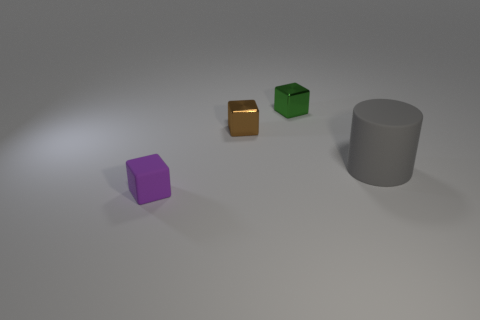Subtract all red blocks. Subtract all green cylinders. How many blocks are left? 3 Add 3 large brown metallic blocks. How many objects exist? 7 Subtract all blocks. How many objects are left? 1 Add 2 tiny blocks. How many tiny blocks are left? 5 Add 4 purple blocks. How many purple blocks exist? 5 Subtract 0 blue balls. How many objects are left? 4 Subtract all small cyan rubber objects. Subtract all metallic things. How many objects are left? 2 